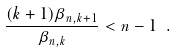<formula> <loc_0><loc_0><loc_500><loc_500>\frac { ( k + 1 ) \beta _ { n , k + 1 } } { \beta _ { n , k } } < n - 1 \ .</formula> 